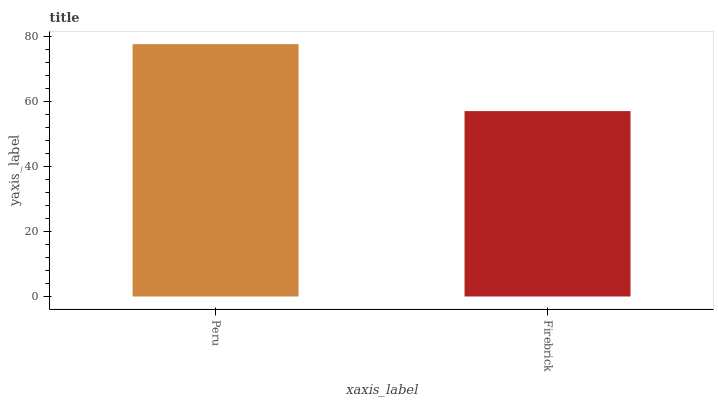Is Firebrick the maximum?
Answer yes or no. No. Is Peru greater than Firebrick?
Answer yes or no. Yes. Is Firebrick less than Peru?
Answer yes or no. Yes. Is Firebrick greater than Peru?
Answer yes or no. No. Is Peru less than Firebrick?
Answer yes or no. No. Is Peru the high median?
Answer yes or no. Yes. Is Firebrick the low median?
Answer yes or no. Yes. Is Firebrick the high median?
Answer yes or no. No. Is Peru the low median?
Answer yes or no. No. 